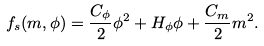Convert formula to latex. <formula><loc_0><loc_0><loc_500><loc_500>f _ { s } ( m , \phi ) = \frac { C _ { \phi } } { 2 } \phi ^ { 2 } + H _ { \phi } \phi + \frac { C _ { m } } { 2 } m ^ { 2 } .</formula> 